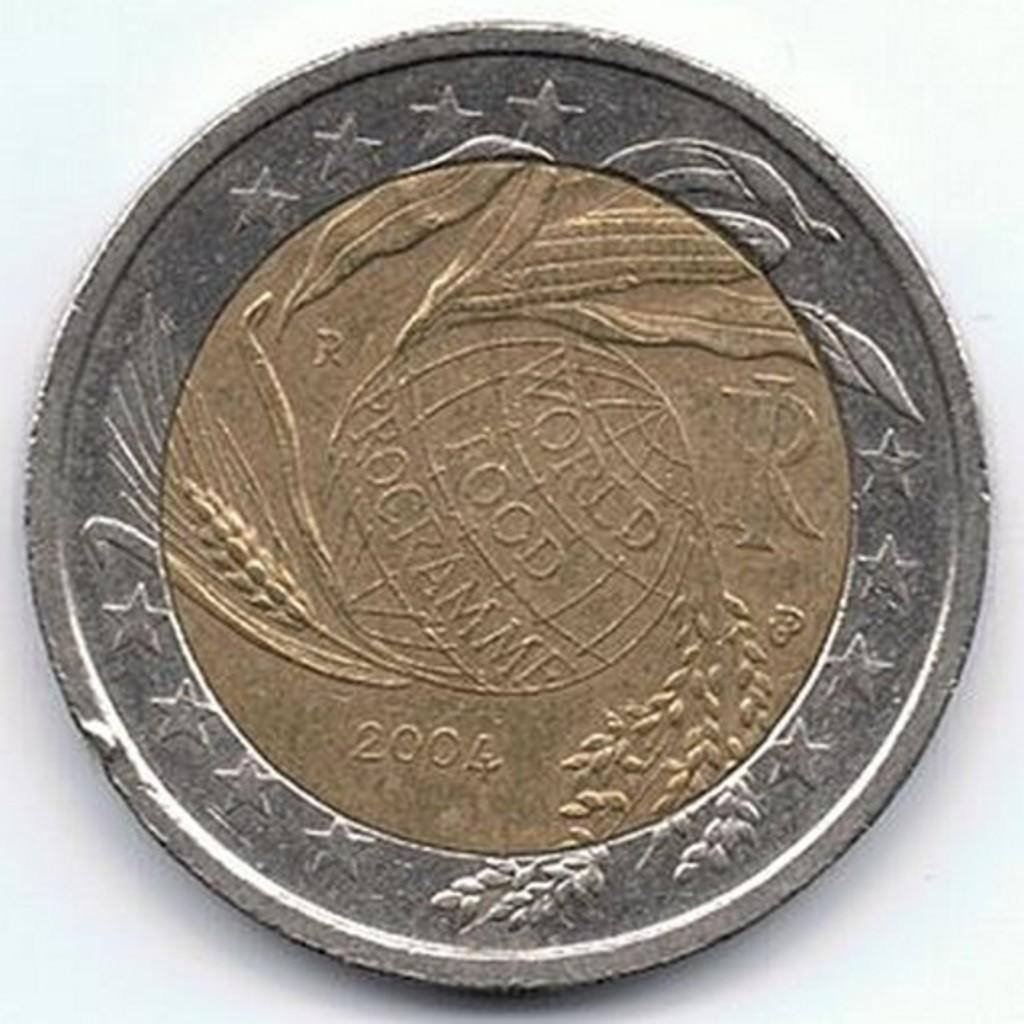<image>
Describe the image concisely. A coin from 2004 that says World Food Programme. 